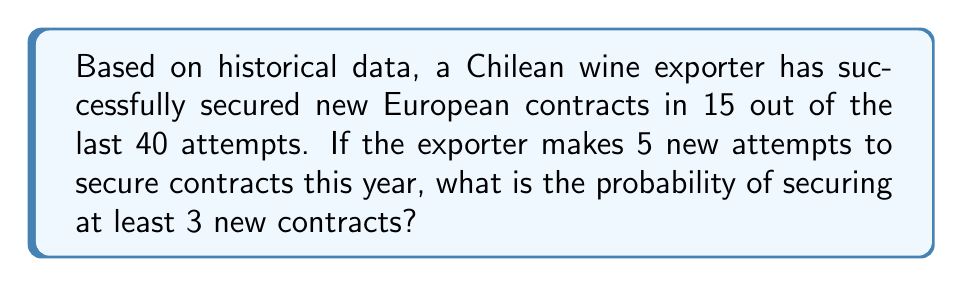Show me your answer to this math problem. To solve this problem, we'll use the binomial probability distribution.

Step 1: Identify the parameters
- $n$ (number of trials) = 5
- $p$ (probability of success) = 15/40 = 0.375
- $q$ (probability of failure) = 1 - p = 0.625
- We want P(X ≥ 3), where X is the number of successes

Step 2: Calculate the probability using the binomial distribution formula
$$P(X \geq 3) = P(X = 3) + P(X = 4) + P(X = 5)$$

For each case:
$$P(X = k) = \binom{n}{k} p^k q^{n-k}$$

Step 3: Calculate each probability
$$P(X = 3) = \binom{5}{3} (0.375)^3 (0.625)^2 = 10 \cdot 0.052734375 \cdot 0.390625 = 0.2059$$
$$P(X = 4) = \binom{5}{4} (0.375)^4 (0.625)^1 = 5 \cdot 0.019775391 \cdot 0.625 = 0.0618$$
$$P(X = 5) = \binom{5}{5} (0.375)^5 (0.625)^0 = 1 \cdot 0.007415771 \cdot 1 = 0.0074$$

Step 4: Sum the probabilities
$$P(X \geq 3) = 0.2059 + 0.0618 + 0.0074 = 0.2751$$

Therefore, the probability of securing at least 3 new contracts out of 5 attempts is approximately 0.2751 or 27.51%.
Answer: 0.2751 